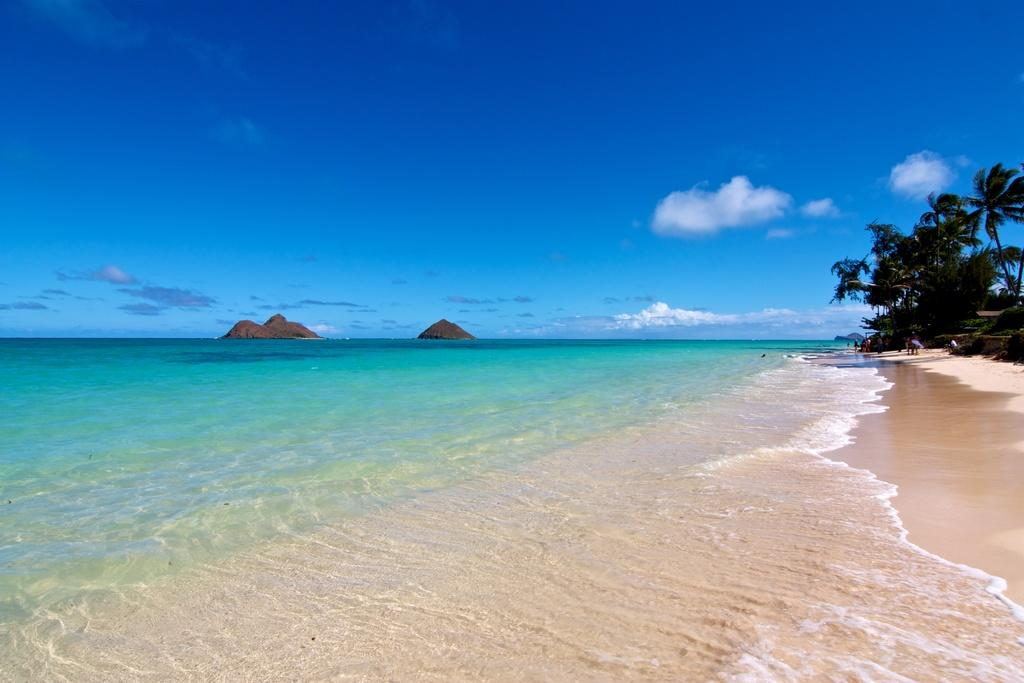What type of natural elements can be seen in the image? There are trees and water visible in the image. What other objects can be found in the image? There are rocks in the image. How would you describe the sky in the image? The sky is blue and cloudy in the image. In which direction is the giraffe facing in the image? There is no giraffe present in the image. 